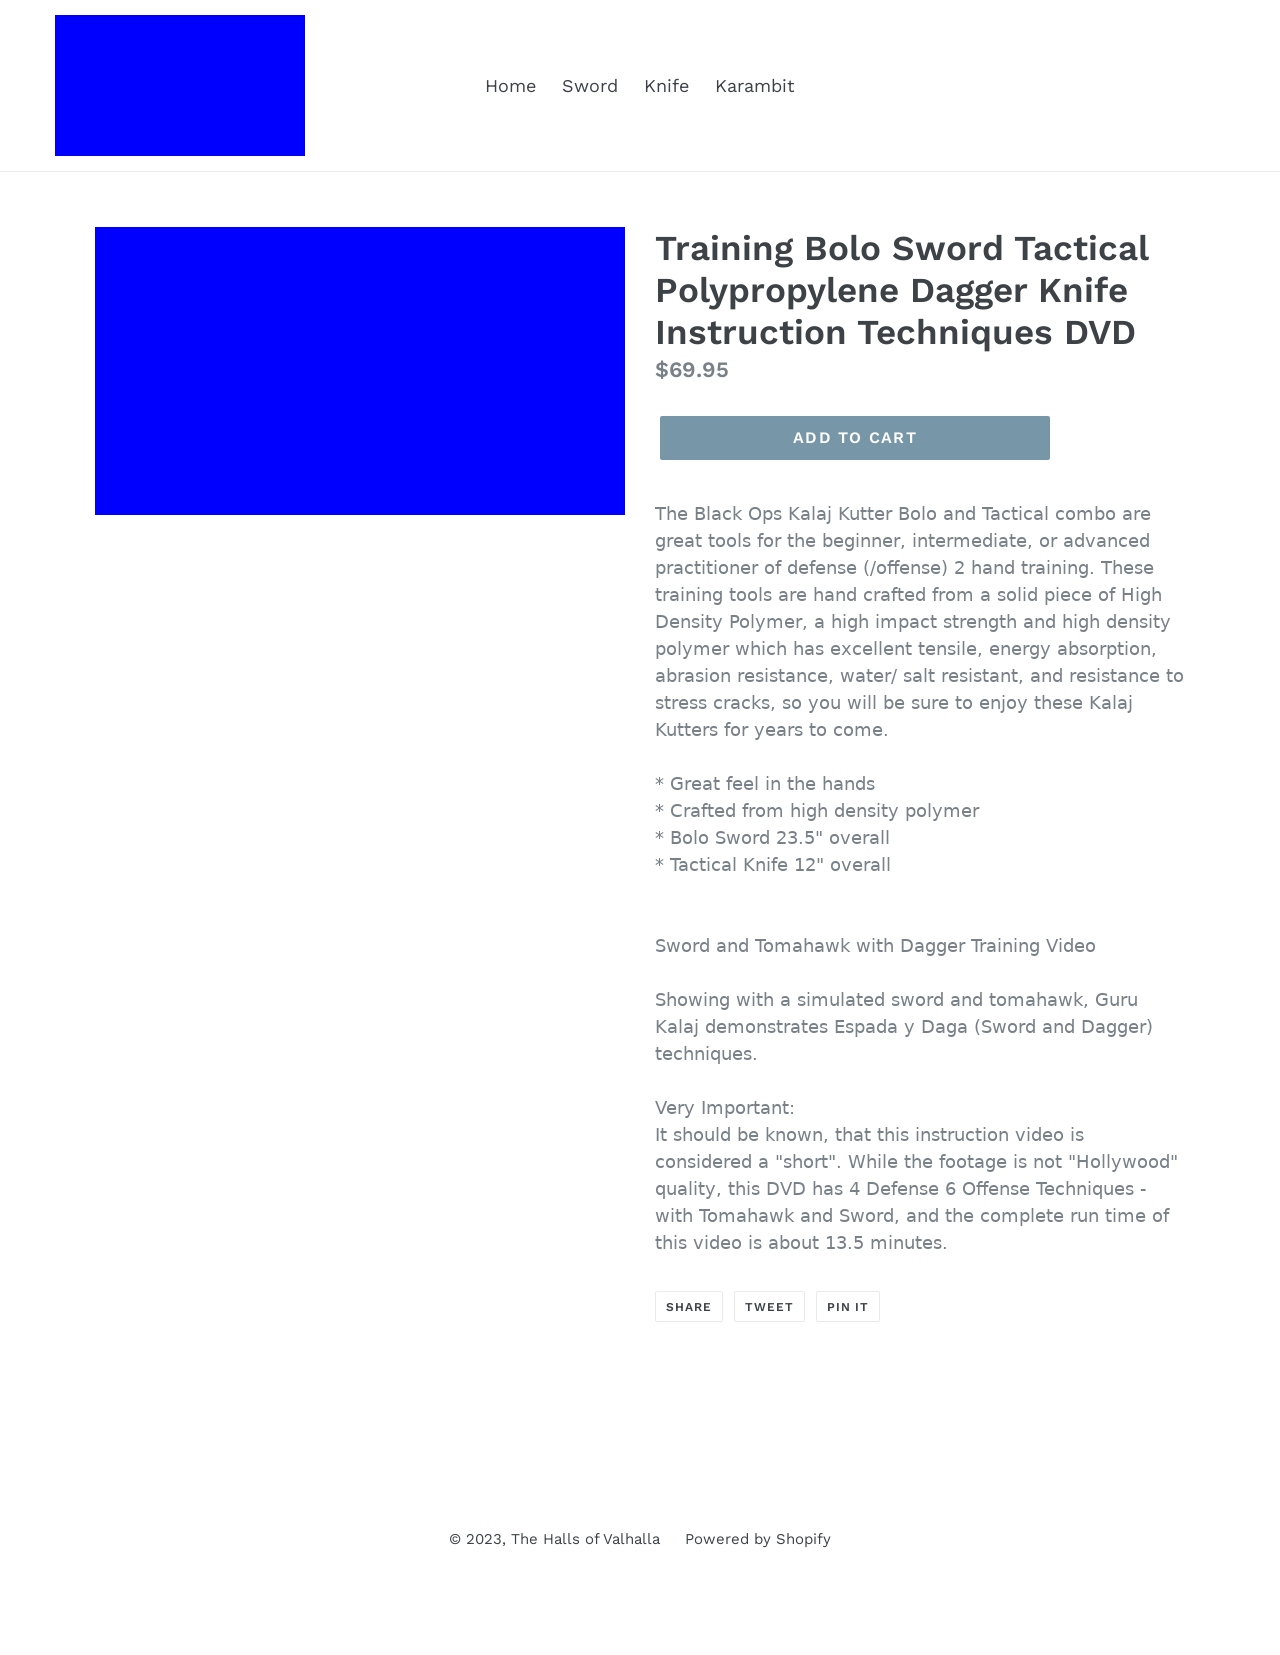How can the material of the products described positively affect a user’s training experience? The high-density polymer used in making the Bolo Sword and Tactical Knife ensures durability and resistance against abrasions and stress, making them ideal for rigorous defense training routines. They provide a safe, reliable alternative to metal, lowering the risk of injury while allowing for effective technique practice. This makes them excellent for practitioners at all levels, ensuring they can train safely and effectively.  Are these products suitable for all levels of martial arts practitioners? Absolutely, the Black Ops Kalaj Kutter Bolo and Tactical Knife are crafted to be used by beginners, intermediate learners, and advanced practitioners. Their design considers the progression in skill levels, allowing users to execute complex maneuvers without the risk associated with sharper blades. 